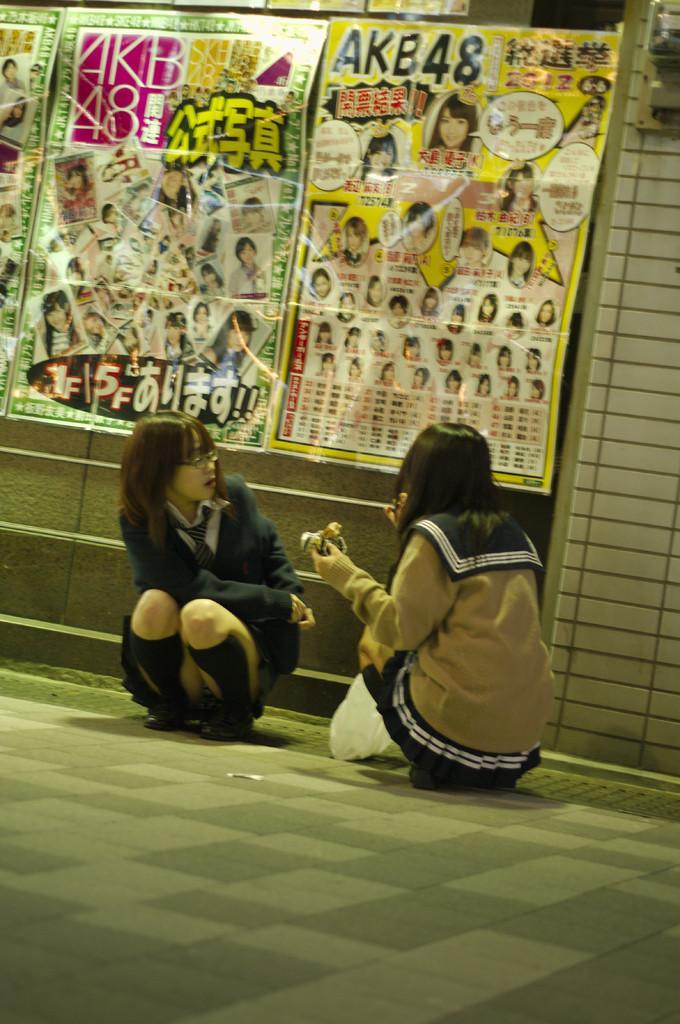Describe this image in one or two sentences. Here 2 girls are sitting, they wore coats and these are the papers that are sticked to the wall. 